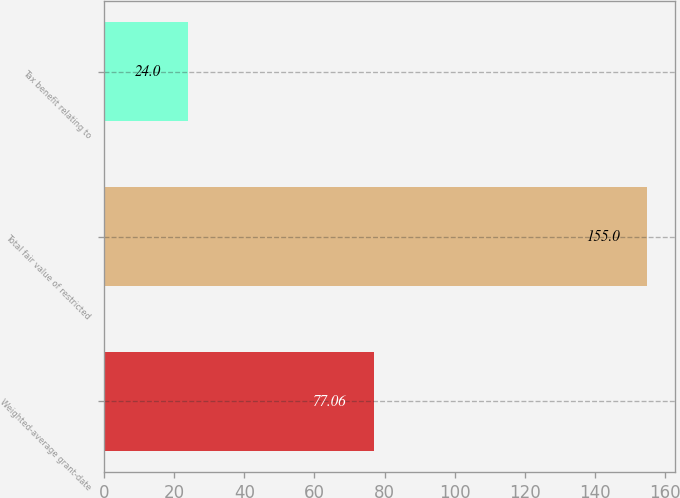<chart> <loc_0><loc_0><loc_500><loc_500><bar_chart><fcel>Weighted-average grant-date<fcel>Total fair value of restricted<fcel>Tax benefit relating to<nl><fcel>77.06<fcel>155<fcel>24<nl></chart> 